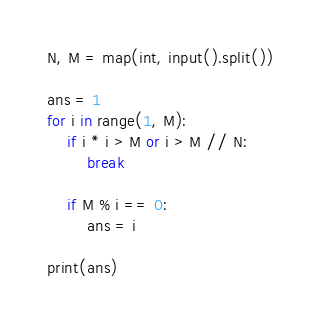Convert code to text. <code><loc_0><loc_0><loc_500><loc_500><_Python_>N, M = map(int, input().split())

ans = 1
for i in range(1, M):
    if i * i > M or i > M // N:
        break
        
    if M % i == 0:
        ans = i
        
print(ans)

</code> 